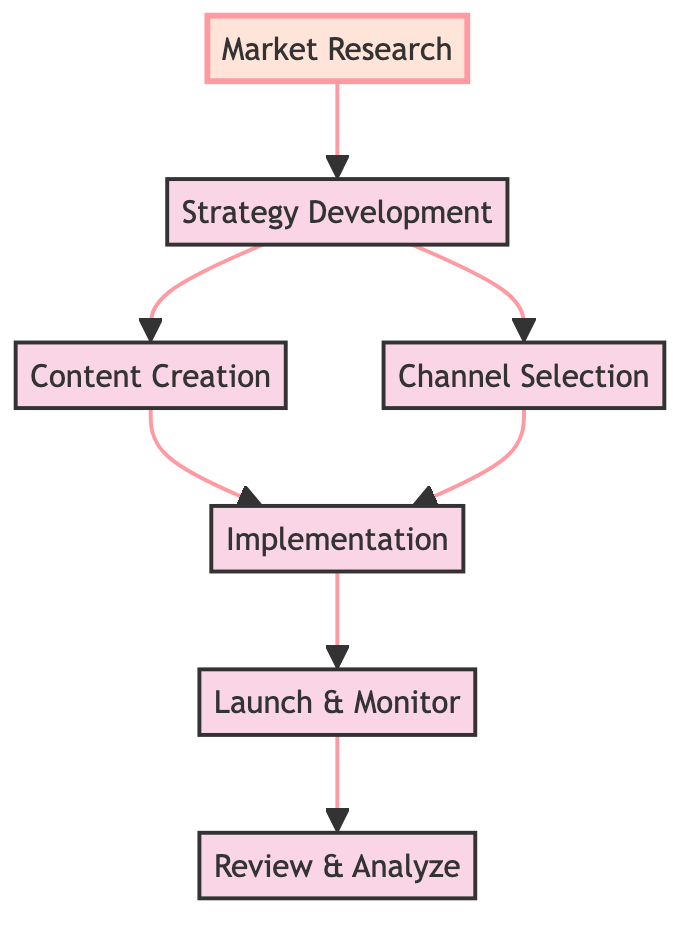What is the first step in the marketing campaign process? The diagram indicates that "Market Research" is the first step because it is the bottommost element and has no incoming connections.
Answer: Market Research How many nodes are there in the diagram? By counting each unique element presented in the diagram, there are a total of seven nodes: Market Research, Strategy Development, Content Creation, Channel Selection, Implementation, Launch & Monitor, and Review & Analyze.
Answer: Seven Which node does "Launch & Monitor" connect to? "Launch & Monitor" has a direct connection to "Implementation," as indicated in the diagram.
Answer: Implementation What are the two nodes connected to "Strategy Development"? The diagram shows that "Strategy Development" connects to both "Content Creation" and "Channel Selection," indicating a branching flow from this step.
Answer: Content Creation, Channel Selection What is the endpoint of the campaign flow? The flow diagram indicates that the final step of the campaign is "Review & Analyze," situated at the topmost point of the flow, which serves as the last activity in the sequence.
Answer: Review & Analyze How many steps are there from "Market Research" to "Review & Analyze"? There are four steps in total: Market Research to Strategy Development, Strategy Development to Content Creation, Strategy Development to Channel Selection, and then to Implementation, followed by Launch & Monitor, and finally to Review & Analyze.
Answer: Four What describes the main purpose of the "Implementation" node? The "Implementation" node's purpose is to execute detailed plans involving various marketing tactics, such as social media posts and email newsletters as stated in the diagram's description.
Answer: Execute detailed plans If the "Channel Selection" is skipped, what will be the impact on the flow? If "Channel Selection" is skipped, the flow would be disrupted after "Strategy Development" as there would be no pathway connecting to "Implementation," highlighting the importance of this step in the overall marketing strategy.
Answer: Disruption of flow What does the arrow direction signify in the diagram? The arrow direction represents the flow of the marketing campaign process, indicating how one step leads to the next in a sequential manner, from the bottom (start) to the top (end).
Answer: Sequential process flow 